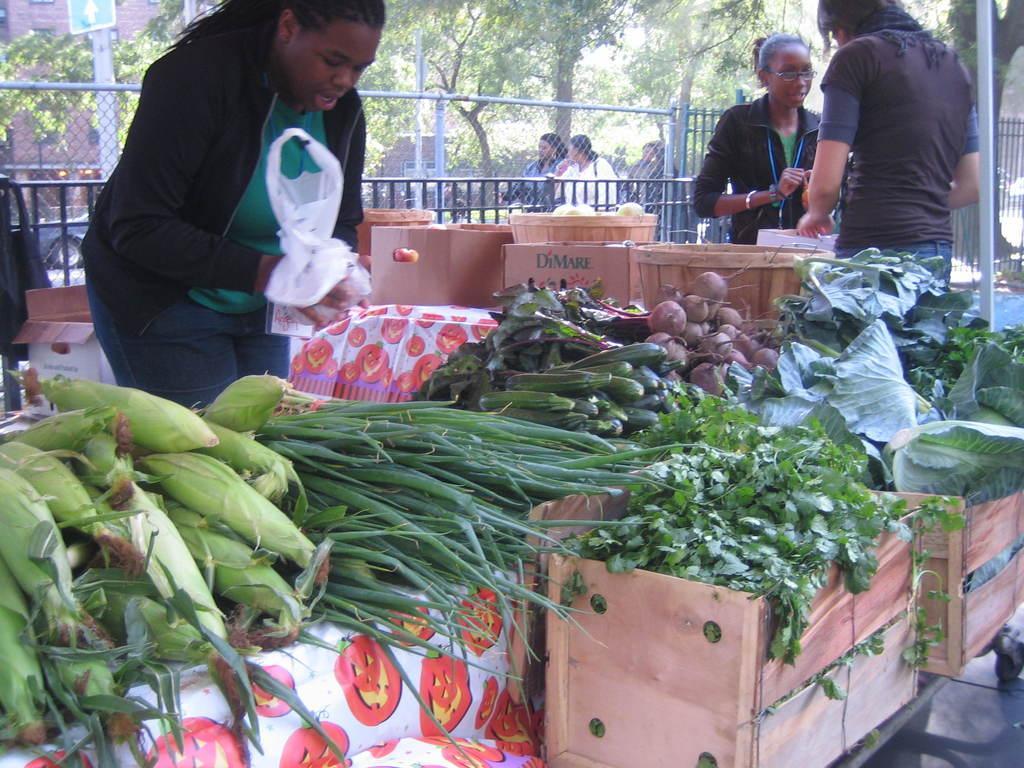Describe this image in one or two sentences. In this image, we can see vegetables, cloth, wooden boxes, carton boxes and few things. Top of the image, we can see few people. Here a person is holding a cover. Background we can see railing, mesh, trees, poles, building and sign board. On the left side of the image, we can see a vehicle. 